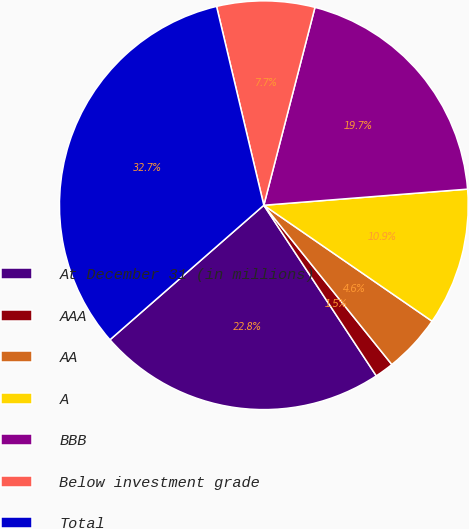Convert chart. <chart><loc_0><loc_0><loc_500><loc_500><pie_chart><fcel>At December 31 (in millions)<fcel>AAA<fcel>AA<fcel>A<fcel>BBB<fcel>Below investment grade<fcel>Total<nl><fcel>22.84%<fcel>1.5%<fcel>4.62%<fcel>10.86%<fcel>19.72%<fcel>7.74%<fcel>32.72%<nl></chart> 